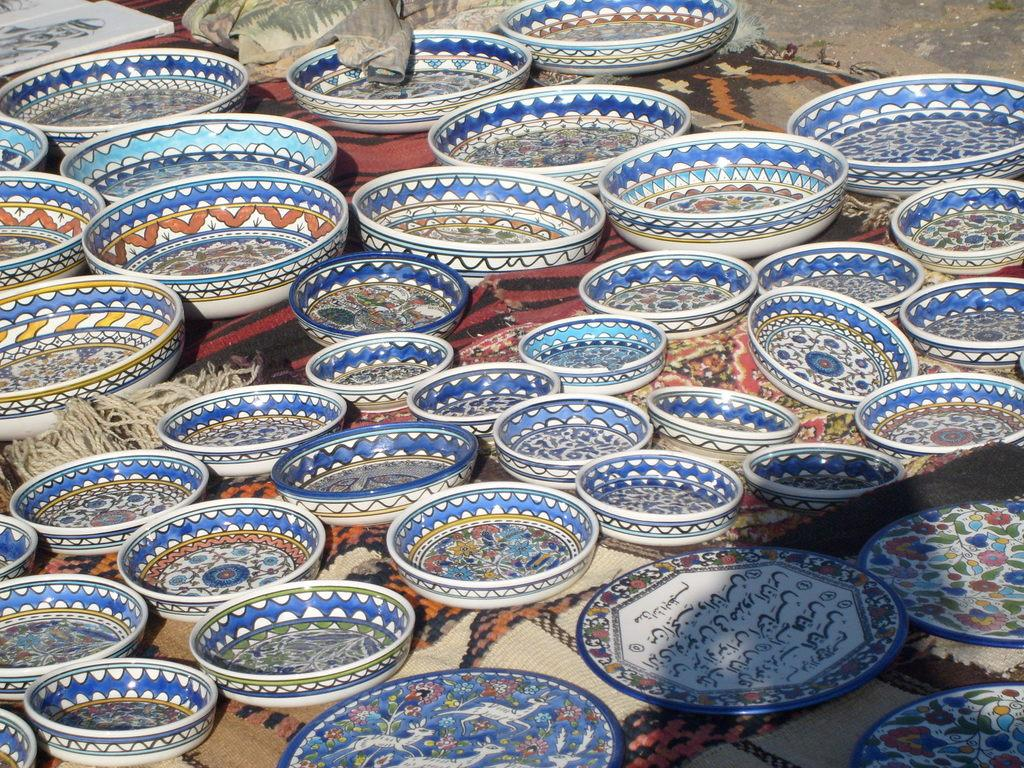What objects are located in the middle of the image? There are blankets in the middle of the image. What items are placed on the blankets? There are bowls and plates on the blankets. What can be seen at the top of the image? There are frames and blankets at the top of the image. What part of the room is visible in the image? The floor is visible in the image. What type of wilderness can be seen in the image? There is no wilderness present in the image; it features blankets, bowls, plates, frames, and a floor. Can you tell me how many eggs are in the nest in the image? There is no nest or eggs present in the image. 